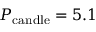<formula> <loc_0><loc_0><loc_500><loc_500>P _ { c a n d l e } = 5 . 1</formula> 